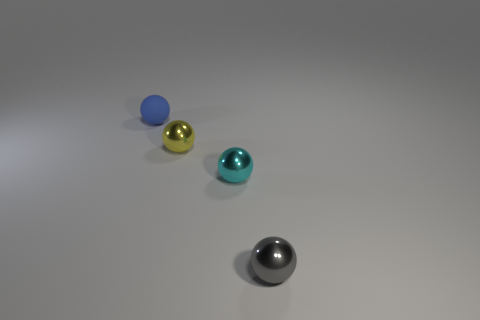Is the number of matte objects that are on the right side of the cyan metal sphere less than the number of blue rubber blocks?
Give a very brief answer. No. What is the shape of the tiny yellow object that is made of the same material as the tiny cyan sphere?
Offer a terse response. Sphere. What number of tiny metal objects have the same color as the small rubber thing?
Make the answer very short. 0. How many objects are either tiny gray objects or small shiny balls?
Make the answer very short. 3. What material is the cyan ball in front of the tiny metallic object on the left side of the cyan ball?
Your answer should be compact. Metal. Is there a tiny yellow ball made of the same material as the tiny blue ball?
Your response must be concise. No. The metal thing in front of the cyan metallic ball on the right side of the metal thing that is to the left of the cyan metallic ball is what shape?
Give a very brief answer. Sphere. What is the tiny yellow object made of?
Ensure brevity in your answer.  Metal. Is there a matte sphere that is behind the metal object that is on the right side of the cyan thing?
Give a very brief answer. Yes. What number of other objects are the same shape as the tiny cyan thing?
Your response must be concise. 3. 